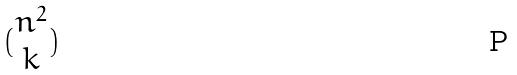<formula> <loc_0><loc_0><loc_500><loc_500>( \begin{matrix} n ^ { 2 } \\ k \end{matrix} )</formula> 